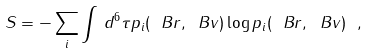Convert formula to latex. <formula><loc_0><loc_0><loc_500><loc_500>S = - \sum _ { i } \int \, d ^ { 6 } \tau p _ { i } ( \ B r , \ B v ) \log p _ { i } ( \ B r , \ B v ) \ ,</formula> 